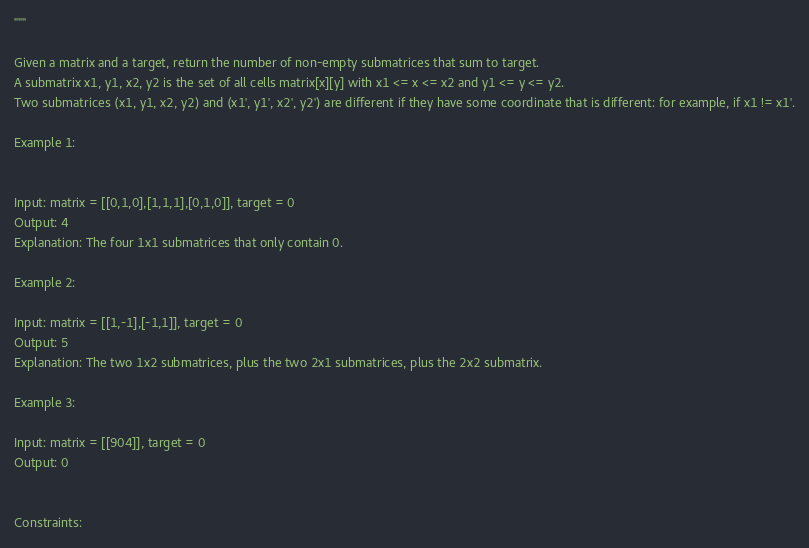<code> <loc_0><loc_0><loc_500><loc_500><_Python_>"""

Given a matrix and a target, return the number of non-empty submatrices that sum to target.
A submatrix x1, y1, x2, y2 is the set of all cells matrix[x][y] with x1 <= x <= x2 and y1 <= y <= y2.
Two submatrices (x1, y1, x2, y2) and (x1', y1', x2', y2') are different if they have some coordinate that is different: for example, if x1 != x1'.
 
Example 1:


Input: matrix = [[0,1,0],[1,1,1],[0,1,0]], target = 0
Output: 4
Explanation: The four 1x1 submatrices that only contain 0.

Example 2:

Input: matrix = [[1,-1],[-1,1]], target = 0
Output: 5
Explanation: The two 1x2 submatrices, plus the two 2x1 submatrices, plus the 2x2 submatrix.

Example 3:

Input: matrix = [[904]], target = 0
Output: 0

 
Constraints:
</code> 